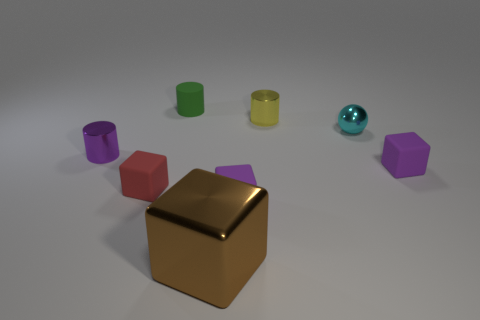Subtract all brown shiny cubes. How many cubes are left? 3 Add 2 big yellow metallic cylinders. How many objects exist? 10 Subtract 1 balls. How many balls are left? 0 Subtract all red spheres. How many purple blocks are left? 2 Subtract all yellow cylinders. How many cylinders are left? 2 Add 7 big brown objects. How many big brown objects are left? 8 Add 3 large purple rubber cubes. How many large purple rubber cubes exist? 3 Subtract 0 yellow balls. How many objects are left? 8 Subtract all cylinders. How many objects are left? 5 Subtract all gray blocks. Subtract all purple cylinders. How many blocks are left? 4 